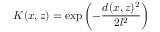<formula> <loc_0><loc_0><loc_500><loc_500>K ( x , z ) = \exp \left ( - \frac { d ( x , z ) ^ { 2 } } { 2 l ^ { 2 } } \right )</formula> 